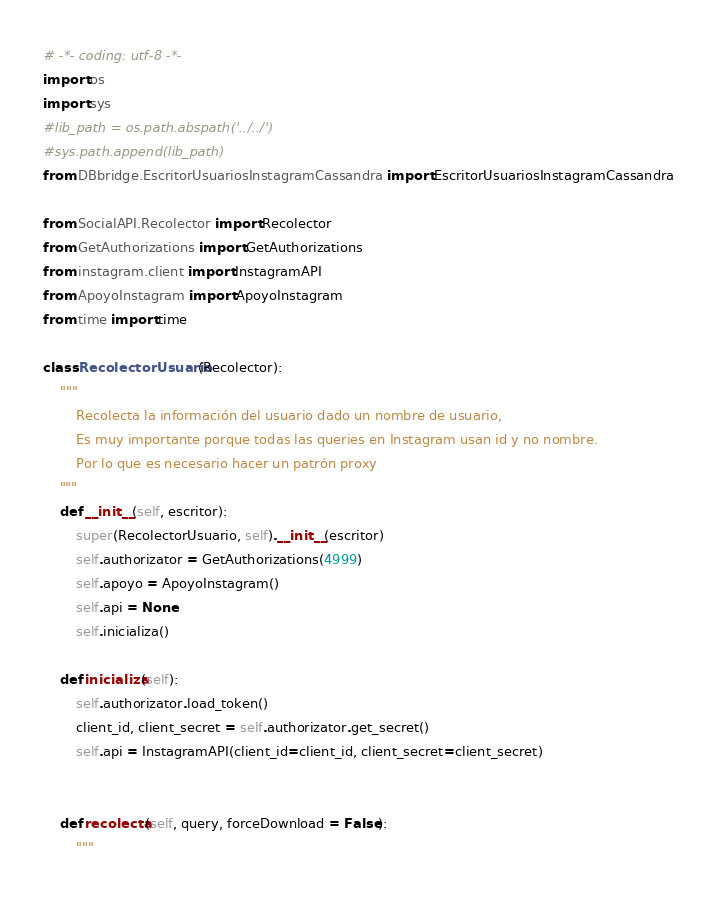Convert code to text. <code><loc_0><loc_0><loc_500><loc_500><_Python_># -*- coding: utf-8 -*-
import os
import sys
#lib_path = os.path.abspath('../../')
#sys.path.append(lib_path)
from DBbridge.EscritorUsuariosInstagramCassandra import EscritorUsuariosInstagramCassandra

from SocialAPI.Recolector import Recolector
from GetAuthorizations import GetAuthorizations
from instagram.client import InstagramAPI
from ApoyoInstagram import ApoyoInstagram
from time import time

class RecolectorUsuario(Recolector):
	"""
		Recolecta la información del usuario dado un nombre de usuario,
		Es muy importante porque todas las queries en Instagram usan id y no nombre.
		Por lo que es necesario hacer un patrón proxy
	"""
	def __init__(self, escritor):
		super(RecolectorUsuario, self).__init__(escritor)
		self.authorizator = GetAuthorizations(4999)
		self.apoyo = ApoyoInstagram()
		self.api = None
		self.inicializa()

	def inicializa(self):
		self.authorizator.load_token()
		client_id, client_secret = self.authorizator.get_secret()
		self.api = InstagramAPI(client_id=client_id, client_secret=client_secret)


	def recolecta(self, query, forceDownload = False):
		"""</code> 